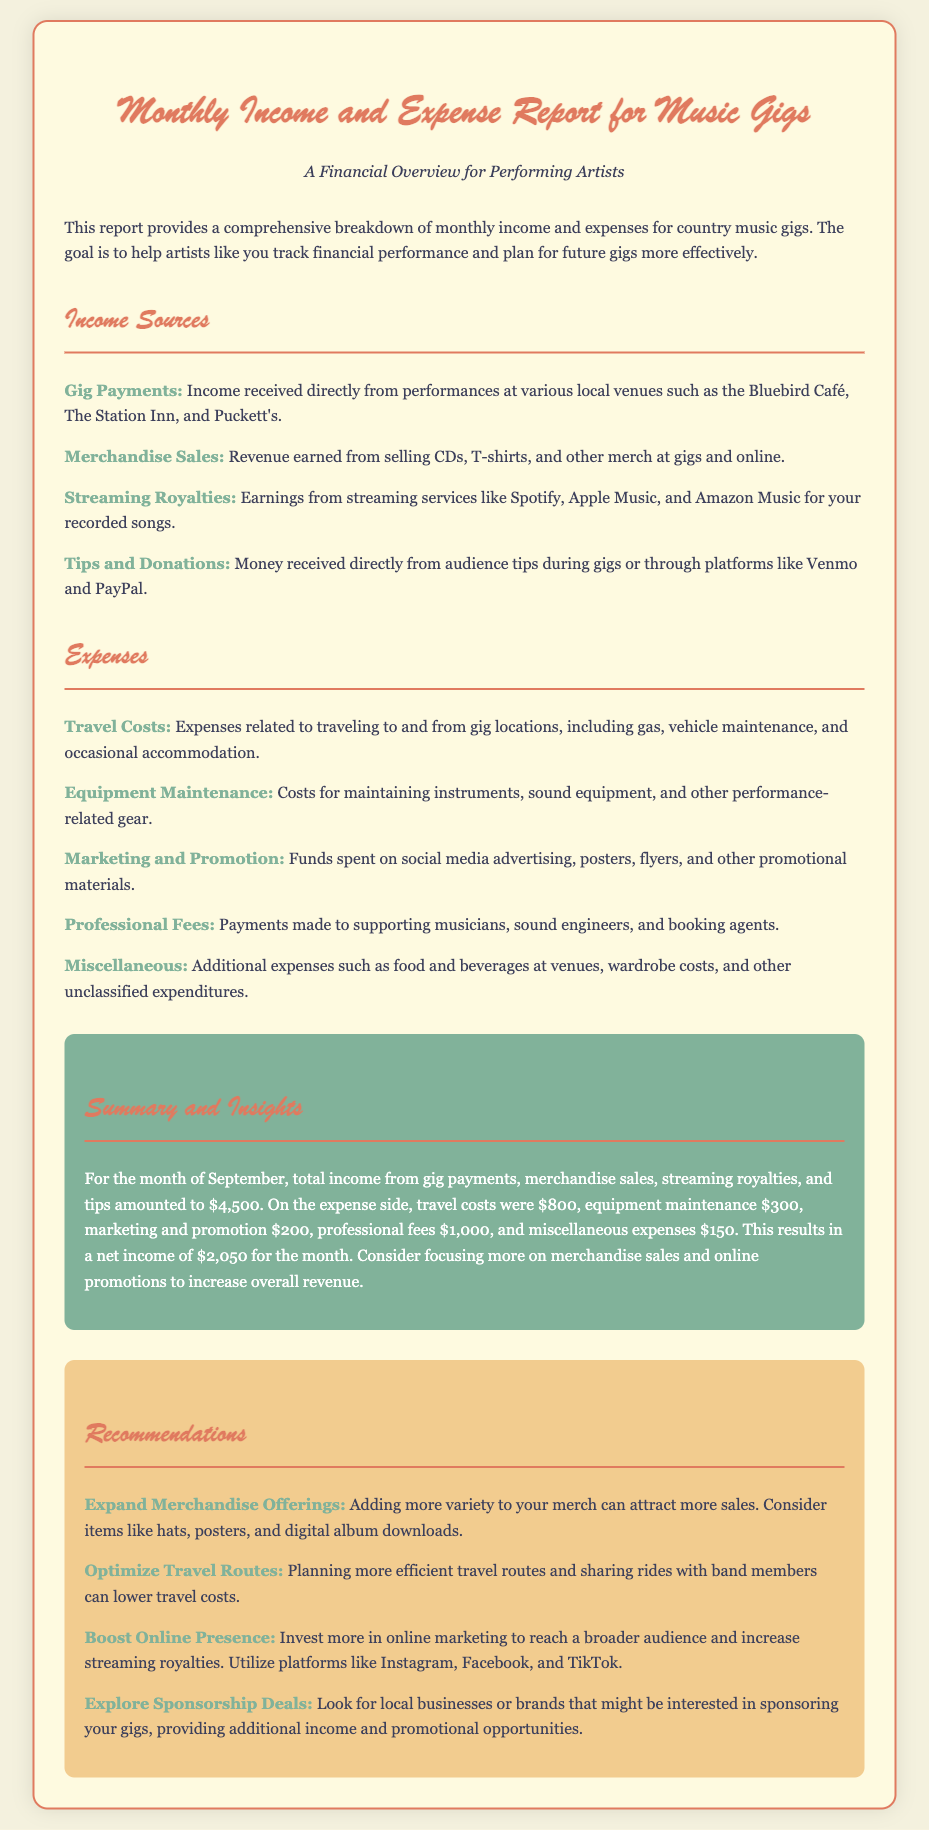What is the total income for September? The total income is provided as the summation of various sources for the month of September, which is $4,500.
Answer: $4,500 What are the expenses related to travel? The document details the expenses incurred for travel, which total $800.
Answer: $800 What are the income sources listed? The report specifies several income sources, including Gig Payments, Merchandise Sales, Streaming Royalties, and Tips and Donations.
Answer: Gig Payments, Merchandise Sales, Streaming Royalties, Tips and Donations What is the net income calculated for the month? The net income is the total income minus total expenses, which calculates to $2,050 for the month.
Answer: $2,050 What is one recommendation for boosting merchandise sales? The document suggests expanding merchandise offerings to attract more sales.
Answer: Expand Merchandise Offerings How much was spent on professional fees? The expenses for professional fees are clearly stated in the document as $1,000.
Answer: $1,000 What type of report is this document? The document is classified as a Monthly Income and Expense Report for Music Gigs, focusing on financial performance.
Answer: Monthly Income and Expense Report for Music Gigs What was the expenditure on marketing and promotion? The document outlines the expense for marketing and promotion, which is $200.
Answer: $200 What is the suggested strategy for optimizing travel costs? The report recommends planning more efficient travel routes and sharing rides with band members.
Answer: Optimize Travel Routes 